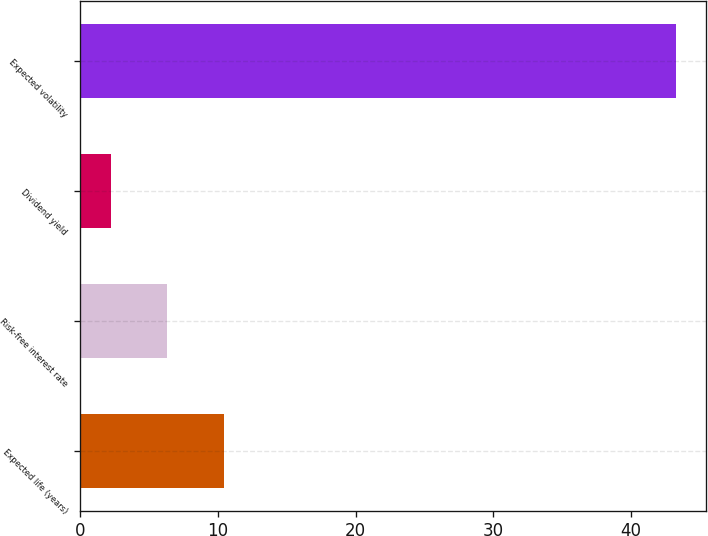<chart> <loc_0><loc_0><loc_500><loc_500><bar_chart><fcel>Expected life (years)<fcel>Risk-free interest rate<fcel>Dividend yield<fcel>Expected volatility<nl><fcel>10.42<fcel>6.31<fcel>2.2<fcel>43.3<nl></chart> 